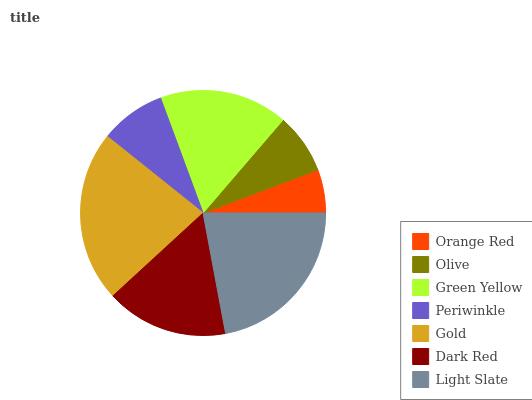Is Orange Red the minimum?
Answer yes or no. Yes. Is Gold the maximum?
Answer yes or no. Yes. Is Olive the minimum?
Answer yes or no. No. Is Olive the maximum?
Answer yes or no. No. Is Olive greater than Orange Red?
Answer yes or no. Yes. Is Orange Red less than Olive?
Answer yes or no. Yes. Is Orange Red greater than Olive?
Answer yes or no. No. Is Olive less than Orange Red?
Answer yes or no. No. Is Dark Red the high median?
Answer yes or no. Yes. Is Dark Red the low median?
Answer yes or no. Yes. Is Green Yellow the high median?
Answer yes or no. No. Is Orange Red the low median?
Answer yes or no. No. 